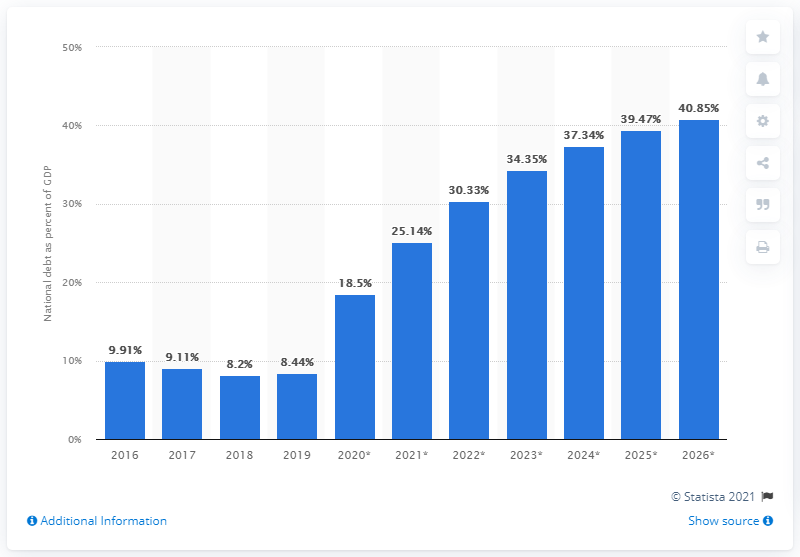Can you explain the significance of the debt-to-GDP ratio for a country's economy? The debt-to-GDP ratio is an important indicator of a country's fiscal health. It provides insights into the country's ability to pay back its debts. A lower ratio suggests a more robust economic position, while a higher ratio may indicate potential financial stress or challenges in managing debt levels. What factors influence changes in the debt-to-GDP ratio? Factors influencing the debt-to-GDP ratio include government fiscal policy, economic growth, interest rates on national debt, and external factors such as trade dynamics and global economic conditions. Policy decisions on taxation and public spending also play a critical role. 